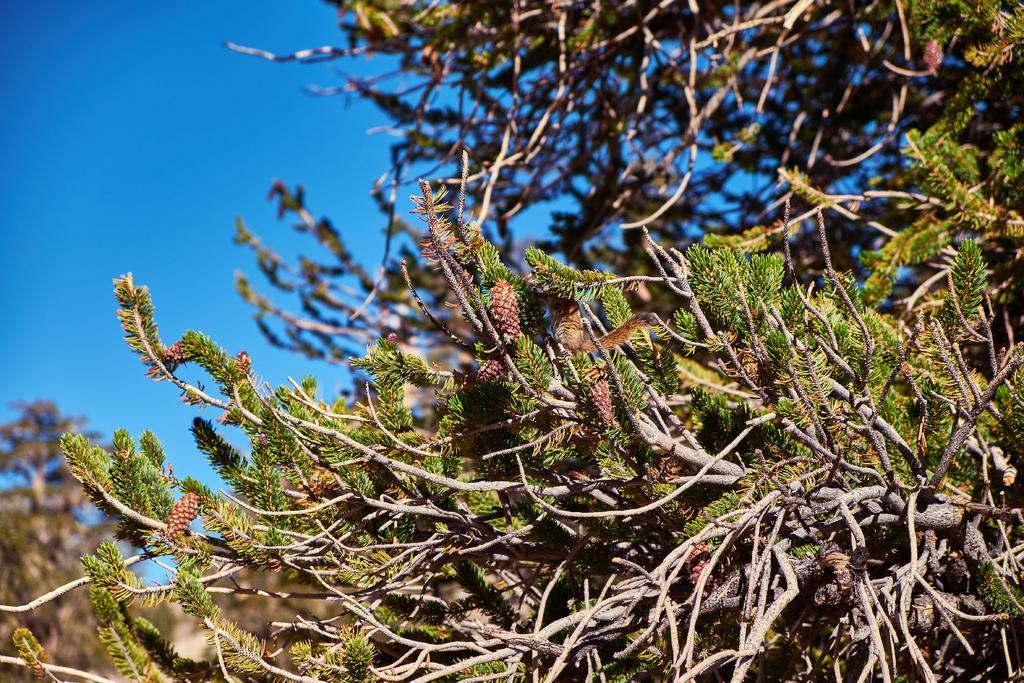Describe this image in one or two sentences. In this image there are few trees having few leaves and fruits to it. A squirrel is sitting on the branches of a tree. Background there is sky. 